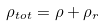<formula> <loc_0><loc_0><loc_500><loc_500>\rho _ { t o t } = \rho + \rho _ { r }</formula> 